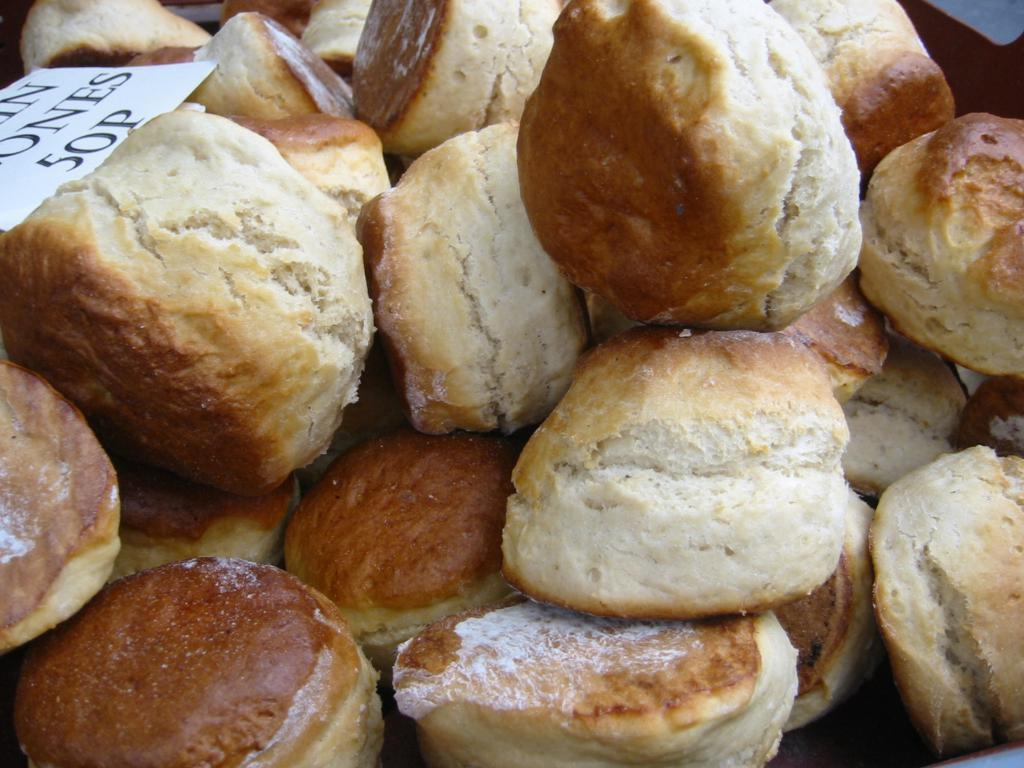What type of food can be seen in the image? There are breads in the image. What is located on the left side of the image? There are papers on the left side of the image. What color is present on the right side of the image? There is a black color on the right side of the image. Can you see any goats in the image? No, there are no goats present in the image. What type of sky is visible in the image? The provided facts do not mention the sky, so we cannot determine the type of sky visible in the image. 